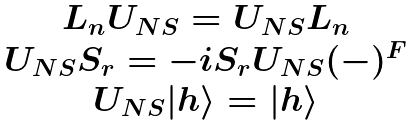<formula> <loc_0><loc_0><loc_500><loc_500>\begin{array} { c } L _ { n } U _ { N S } = U _ { N S } L _ { n } \\ U _ { N S } S _ { r } = - i S _ { r } U _ { N S } ( - ) ^ { F } \\ U _ { N S } | h \rangle = | h \rangle \end{array}</formula> 